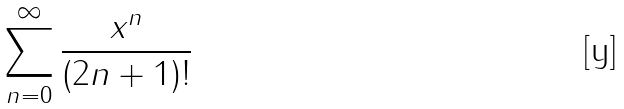Convert formula to latex. <formula><loc_0><loc_0><loc_500><loc_500>\sum _ { n = 0 } ^ { \infty } \frac { x ^ { n } } { ( 2 n + 1 ) ! }</formula> 